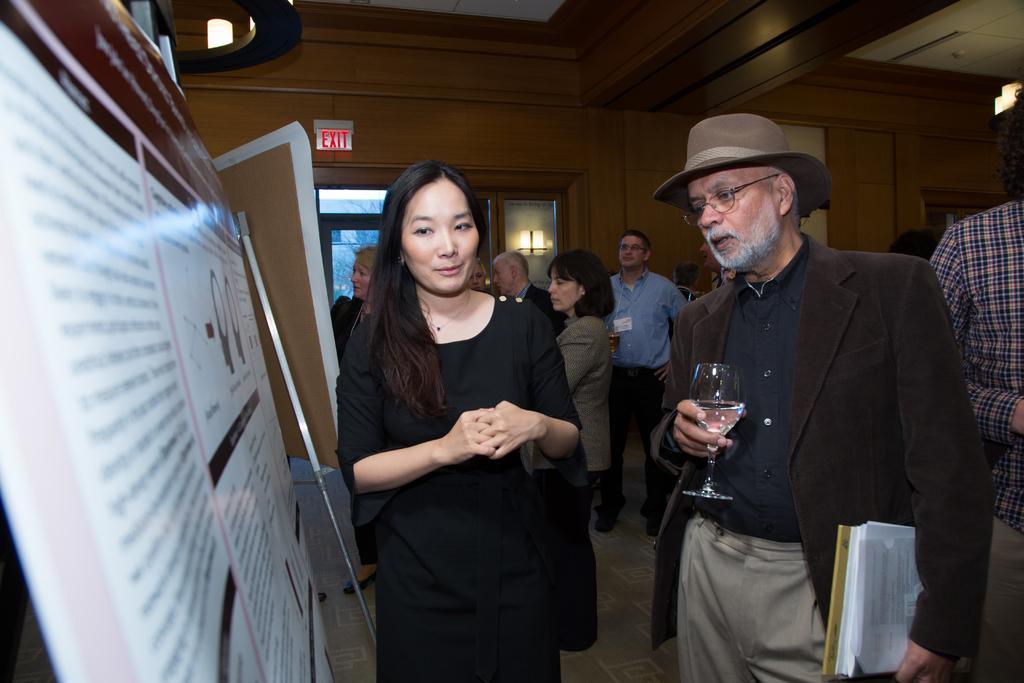Describe this image in one or two sentences. In this image I can see number of people are standing and in the front I can see one man is holding a glass and few white colour papers. I can see he is wearing a specs, a hat, shirt, pant and a blazer. On the left side I can see two boards and on one board I can see something is written. In the background I can see a door, a window and an exit sign board. I can also see few lights on the both sides of the image. 